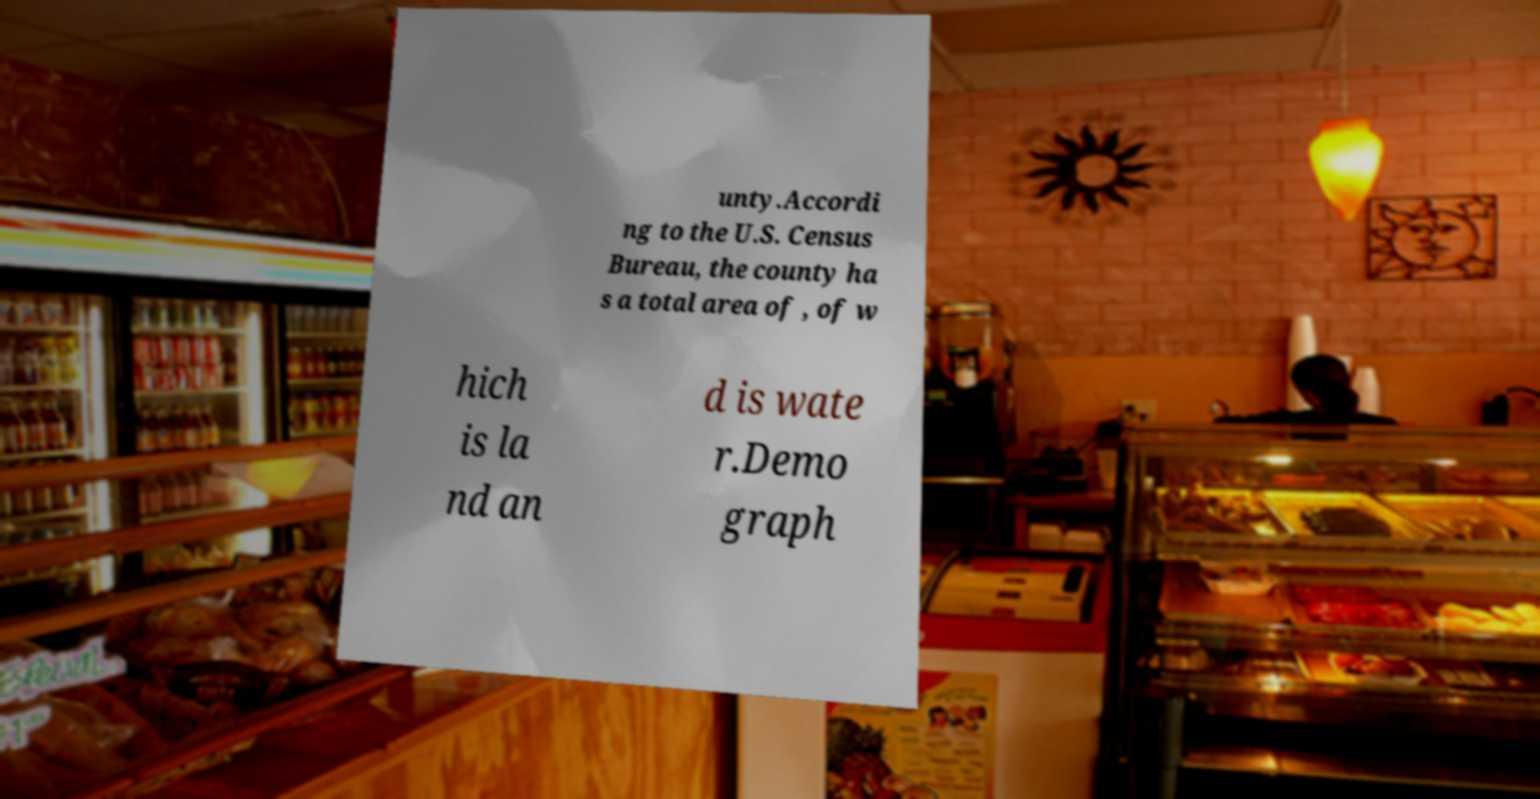What messages or text are displayed in this image? I need them in a readable, typed format. unty.Accordi ng to the U.S. Census Bureau, the county ha s a total area of , of w hich is la nd an d is wate r.Demo graph 